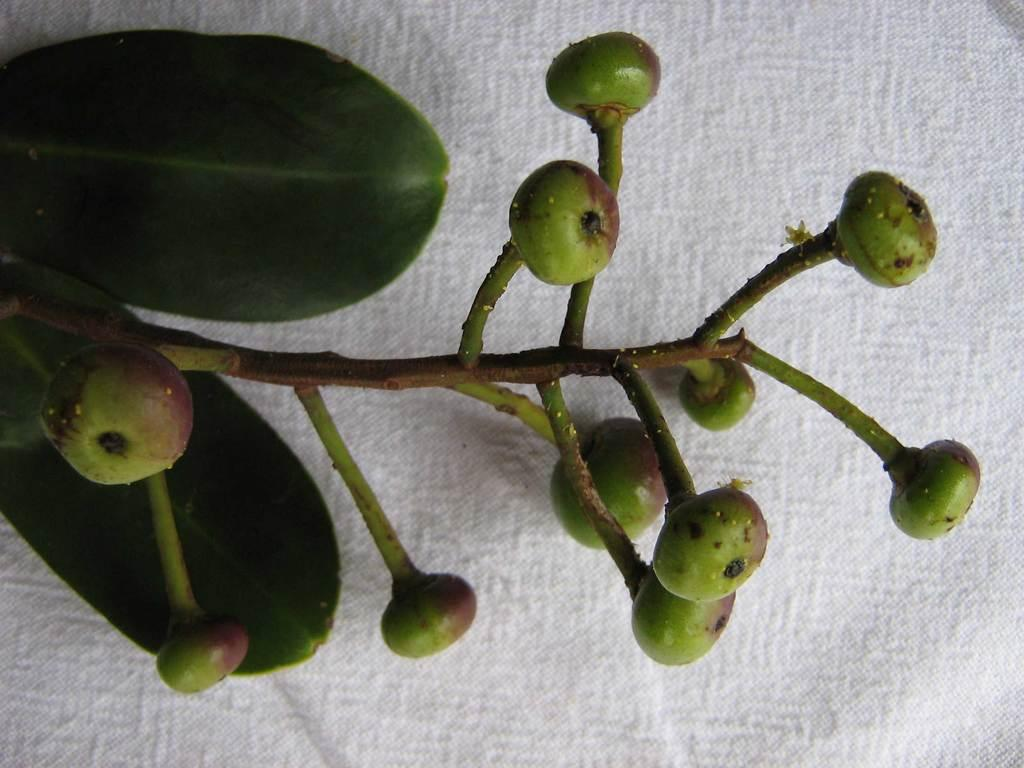What is the main object in the image? There is a stem in the image. How many leaves are attached to the stem? There are two leaves in the image. What is the stage of development of the fruits in the image? Unripe fruits are visible in the image. What color is the cloth in the image? The image features a white color cloth. What type of tank is visible in the image? There is no tank present in the image. Can you describe the father's expression in the image? There is no father or any person present in the image. 